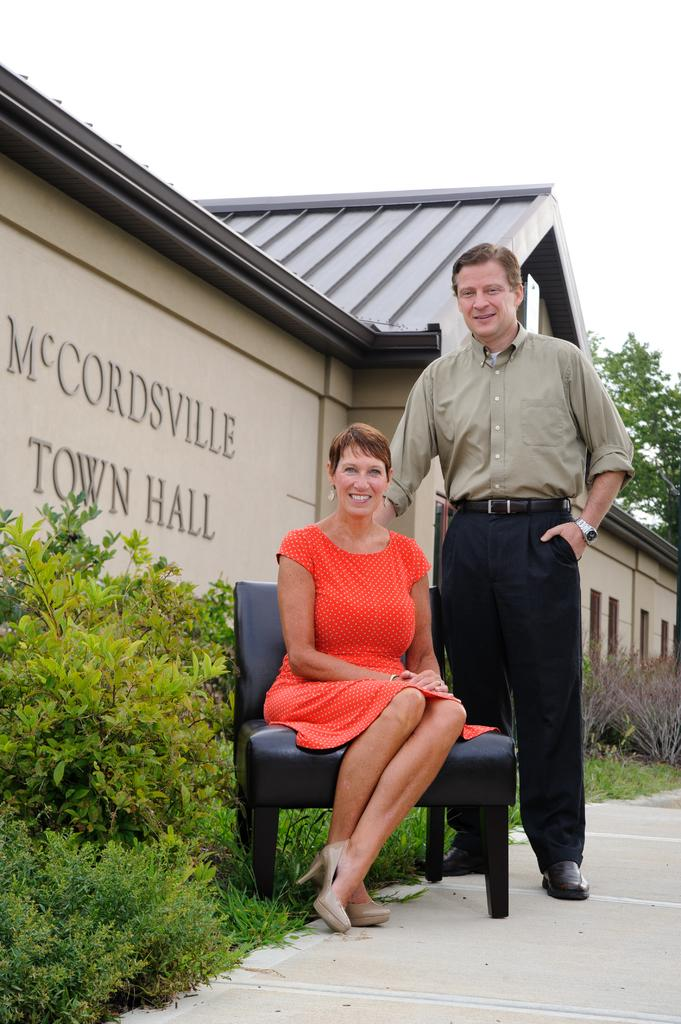How many people are present in the image? There are two people, a man and a woman, present in the image. What is the woman doing in the image? The woman is seated on a chair in the image. What can be seen in the background of the image? There are plants, trees, and at least one building visible in the background of the image. What type of ear is visible on the man in the image? There is no ear visible on the man in the image. What is the weather like during the week depicted in the image? The image does not depict a specific week or weather conditions; it simply shows a man and a woman in a setting with plants, trees, and a building in the background. 